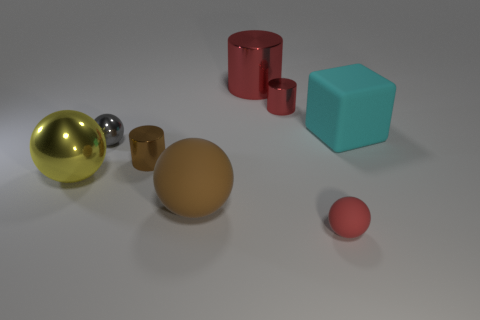How many rubber things are large gray cubes or brown cylinders?
Provide a short and direct response. 0. Does the yellow thing have the same size as the gray metallic ball?
Provide a succinct answer. No. Are there fewer metal objects on the right side of the large brown rubber thing than spheres that are in front of the big matte cube?
Offer a very short reply. Yes. How big is the gray metal object?
Provide a succinct answer. Small. How many big objects are red shiny cylinders or brown balls?
Provide a succinct answer. 2. There is a brown metal cylinder; is it the same size as the rubber cube that is behind the brown rubber ball?
Make the answer very short. No. Is there any other thing that is the same shape as the cyan thing?
Give a very brief answer. No. How many large purple rubber objects are there?
Offer a terse response. 0. What number of red objects are either tiny matte things or metallic things?
Make the answer very short. 3. Does the tiny sphere that is on the left side of the big red cylinder have the same material as the small brown cylinder?
Your answer should be compact. Yes. 